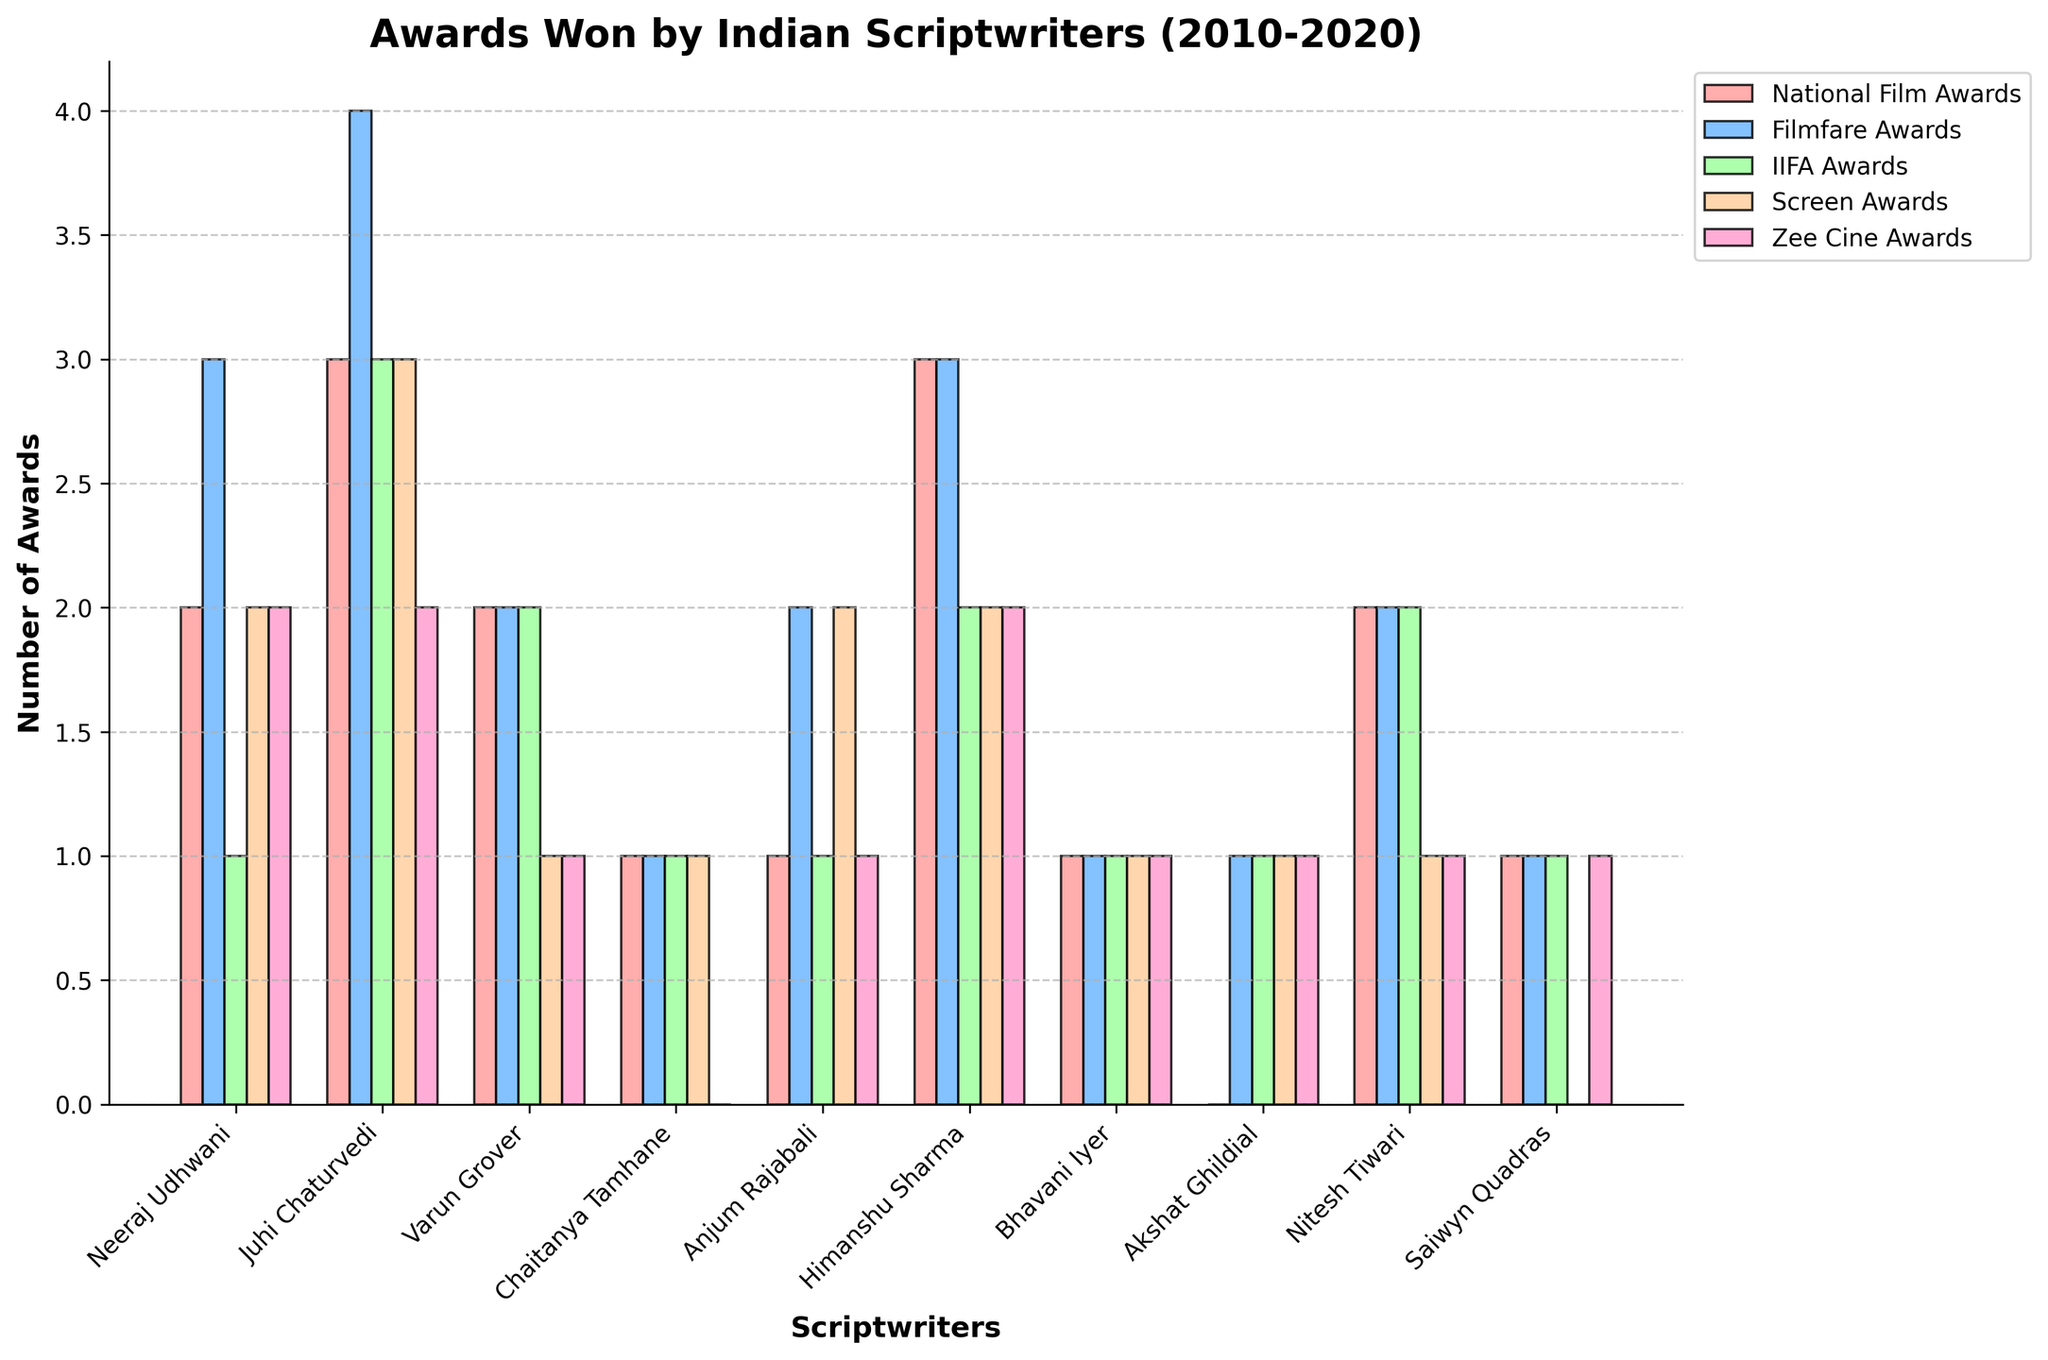Which scriptwriter has won the most Filmfare Awards? To find which scriptwriter has the highest number of Filmfare Awards, we look at the height of the bars under the Filmfare Awards category. Juhi Chaturvedi has the tallest bar with 4 awards.
Answer: Juhi Chaturvedi How many total awards has Neeraj Udhwani won? Sum the number of awards Neeraj Udhwani won across all categories: 2 (National Film Awards) + 3 (Filmfare Awards) + 1 (IIFA Awards) + 2 (Screen Awards) + 2 (Zee Cine Awards) = 10.
Answer: 10 Who has won an equal number of National Film Awards and IIFA Awards? To determine this, compare the heights of the bars in the National Film Awards and IIFA Awards for each scriptwriter. Both Varun Grover and Nitesh Tiwari have equal height bars in these categories (2 awards each).
Answer: Varun Grover, Nitesh Tiwari Which category has the most awards for Himanshu Sharma? For Himanshu Sharma, we compare the heights of the bars across categories. National Film Awards and Filmfare Awards both have the tallest bars with 3 awards each.
Answer: National Film Awards, Filmfare Awards Between Anjum Rajabali and Saiwyn Quadras, who has won more awards in total? Sum the awards for each:
Anjum Rajabali: 1 (National Film Awards) + 2 (Filmfare Awards) + 1 (IIFA Awards) + 2 (Screen Awards) + 1 (Zee Cine Awards) = 7
Saiwyn Quadras: 1 (National Film Awards) + 1 (Filmfare Awards) + 1 (IIFA Awards) + 0 (Screen Awards) + 1 (Zee Cine Awards) = 4
Anjum Rajabali has more total awards.
Answer: Anjum Rajabali Which scriptwriter has consistently won at least one award in each category? Look for scriptwriters with at least one bar in each category. Bhavani Iyer and Nitesh Tiwari have equal height bars in these categories, indicating at least one award in each category.
Answer: Bhavani Iyer, Nitesh Tiwari In which category does Chaitanya Tamhane have zero awards? Identify the bar that is not present for Chaitanya Tamhane. The Zee Cine Awards category has no bar for him, indicating zero awards.
Answer: Zee Cine Awards How many more awards has Juhi Chaturvedi won compared to Chaitanya Tamhane? First, find the total awards for both:
Juhi Chaturvedi: 3 (National Film Awards) + 4 (Filmfare Awards) + 3 (IIFA Awards) + 3 (Screen Awards) + 2 (Zee Cine Awards) = 15
Chaitanya Tamhane: 1 (National Film Awards) + 1 (Filmfare Awards) + 1 (IIFA Awards) + 1 (Screen Awards) + 0 (Zee Cine Awards) = 4
Juhi Chaturvedi has won 15 - 4 = 11 more awards.
Answer: 11 Which scriptwriter has an identical number of awards across National Film Awards, IIFA Awards, and Screen Awards? Check for scriptwriters with equal bars in these three categories. Bhavani Iyer has identical bar heights in the National Film Awards, IIFA Awards, and Screen Awards (1 each).
Answer: Bhavani Iyer 